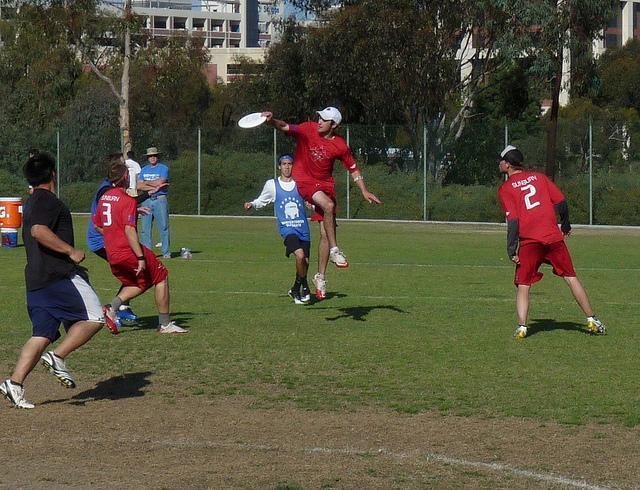How many teams are playing this sport?
Give a very brief answer. 2. How many people are wearing red?
Give a very brief answer. 3. How many people in the shot?
Give a very brief answer. 8. How many people can be seen?
Give a very brief answer. 6. How many elephants are in this picture?
Give a very brief answer. 0. 